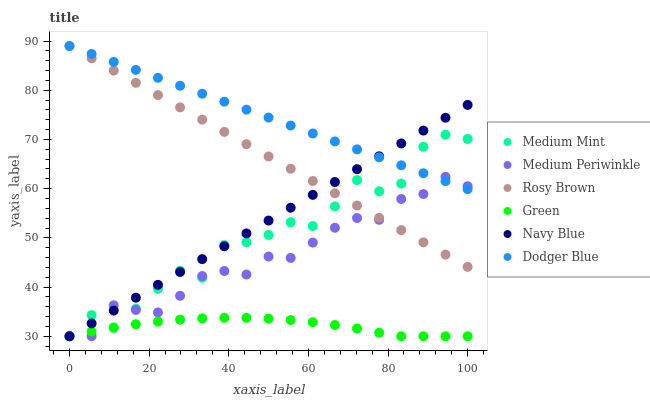Does Green have the minimum area under the curve?
Answer yes or no. Yes. Does Dodger Blue have the maximum area under the curve?
Answer yes or no. Yes. Does Navy Blue have the minimum area under the curve?
Answer yes or no. No. Does Navy Blue have the maximum area under the curve?
Answer yes or no. No. Is Dodger Blue the smoothest?
Answer yes or no. Yes. Is Medium Mint the roughest?
Answer yes or no. Yes. Is Navy Blue the smoothest?
Answer yes or no. No. Is Navy Blue the roughest?
Answer yes or no. No. Does Medium Mint have the lowest value?
Answer yes or no. Yes. Does Rosy Brown have the lowest value?
Answer yes or no. No. Does Dodger Blue have the highest value?
Answer yes or no. Yes. Does Navy Blue have the highest value?
Answer yes or no. No. Is Green less than Dodger Blue?
Answer yes or no. Yes. Is Rosy Brown greater than Green?
Answer yes or no. Yes. Does Navy Blue intersect Green?
Answer yes or no. Yes. Is Navy Blue less than Green?
Answer yes or no. No. Is Navy Blue greater than Green?
Answer yes or no. No. Does Green intersect Dodger Blue?
Answer yes or no. No. 